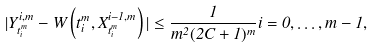<formula> <loc_0><loc_0><loc_500><loc_500>| Y _ { t _ { i } ^ { m } } ^ { i , m } - W \left ( t _ { i } ^ { m } , X _ { t _ { i } ^ { m } } ^ { i - 1 , m } \right ) | \leq \frac { 1 } { m ^ { 2 } ( 2 C + 1 ) ^ { m } } i = 0 , \dots , m - 1 ,</formula> 